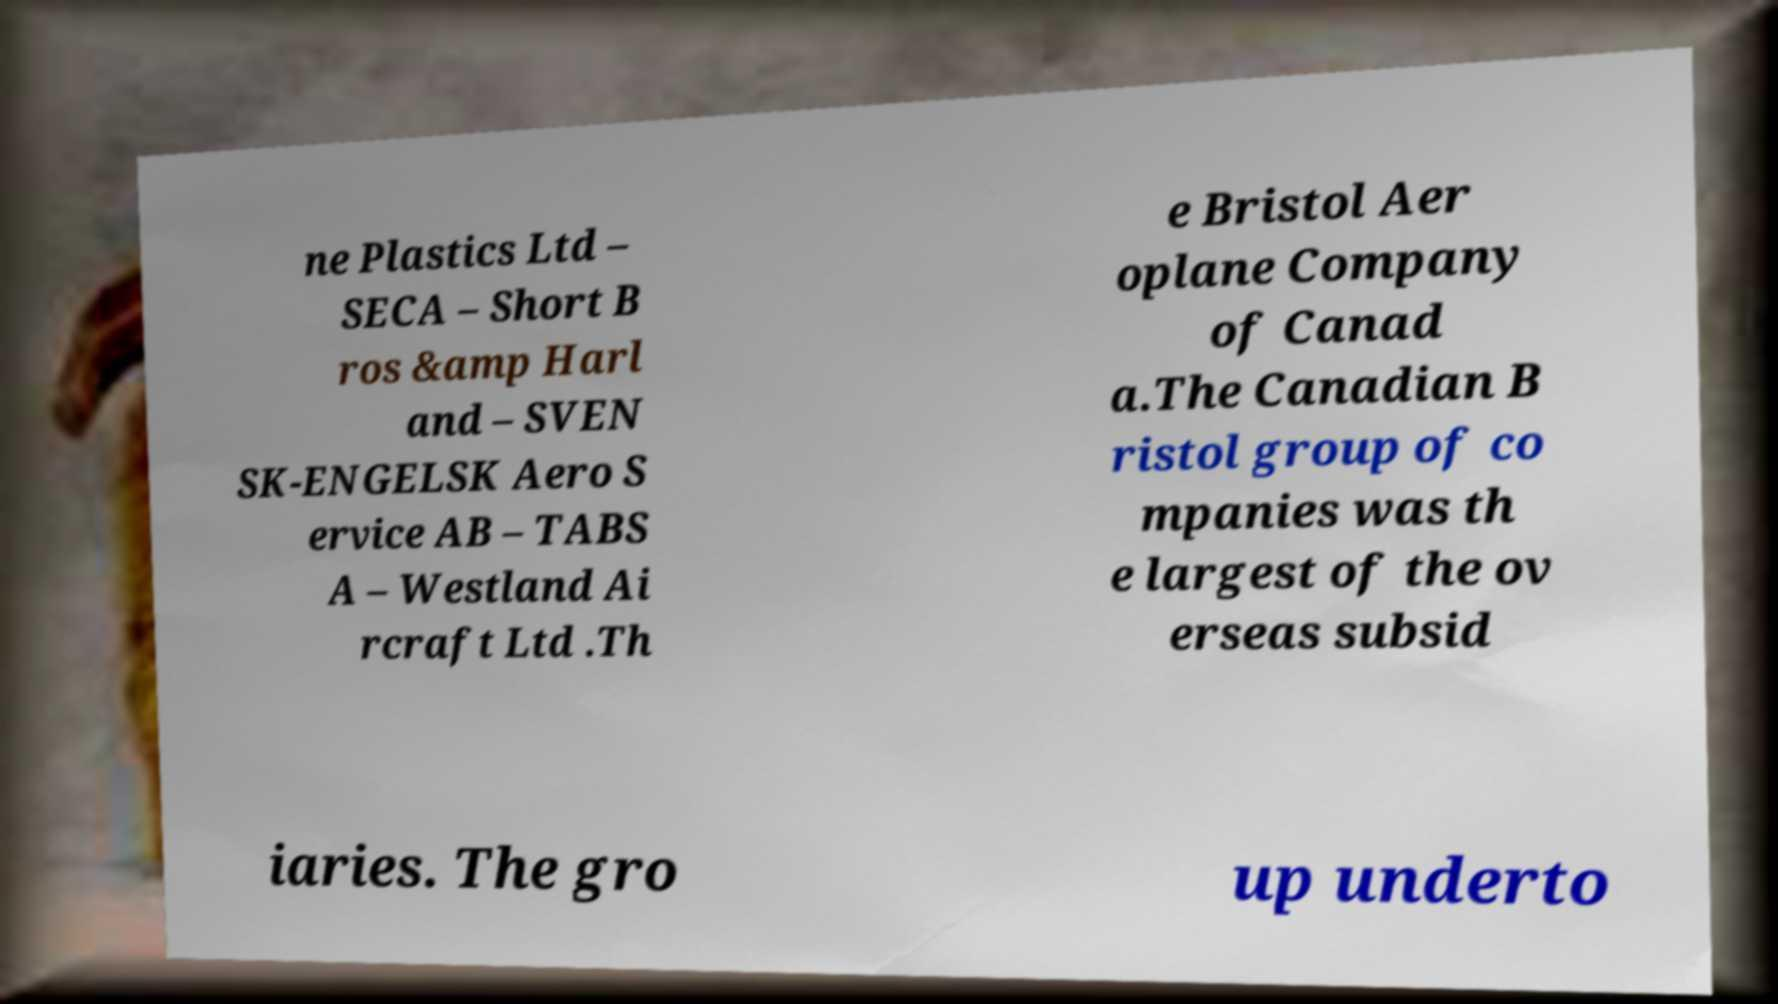Can you accurately transcribe the text from the provided image for me? ne Plastics Ltd – SECA – Short B ros &amp Harl and – SVEN SK-ENGELSK Aero S ervice AB – TABS A – Westland Ai rcraft Ltd .Th e Bristol Aer oplane Company of Canad a.The Canadian B ristol group of co mpanies was th e largest of the ov erseas subsid iaries. The gro up underto 